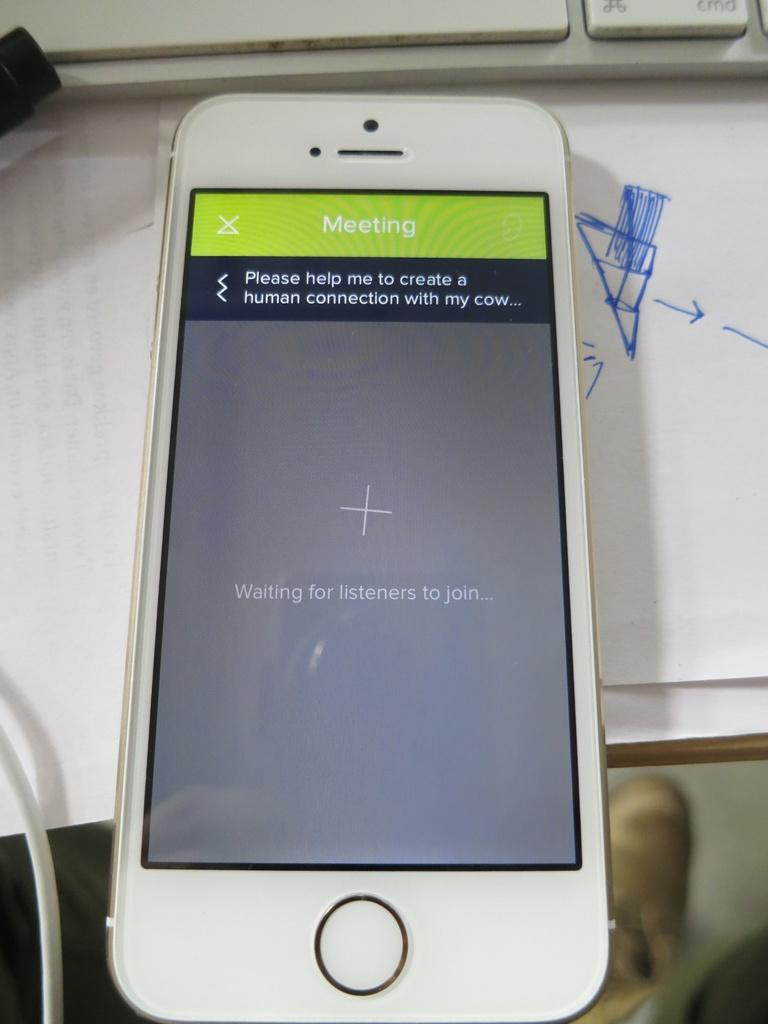<image>
Describe the image concisely. An electronic device showing a meeting with a question about making a connection with a cow. 